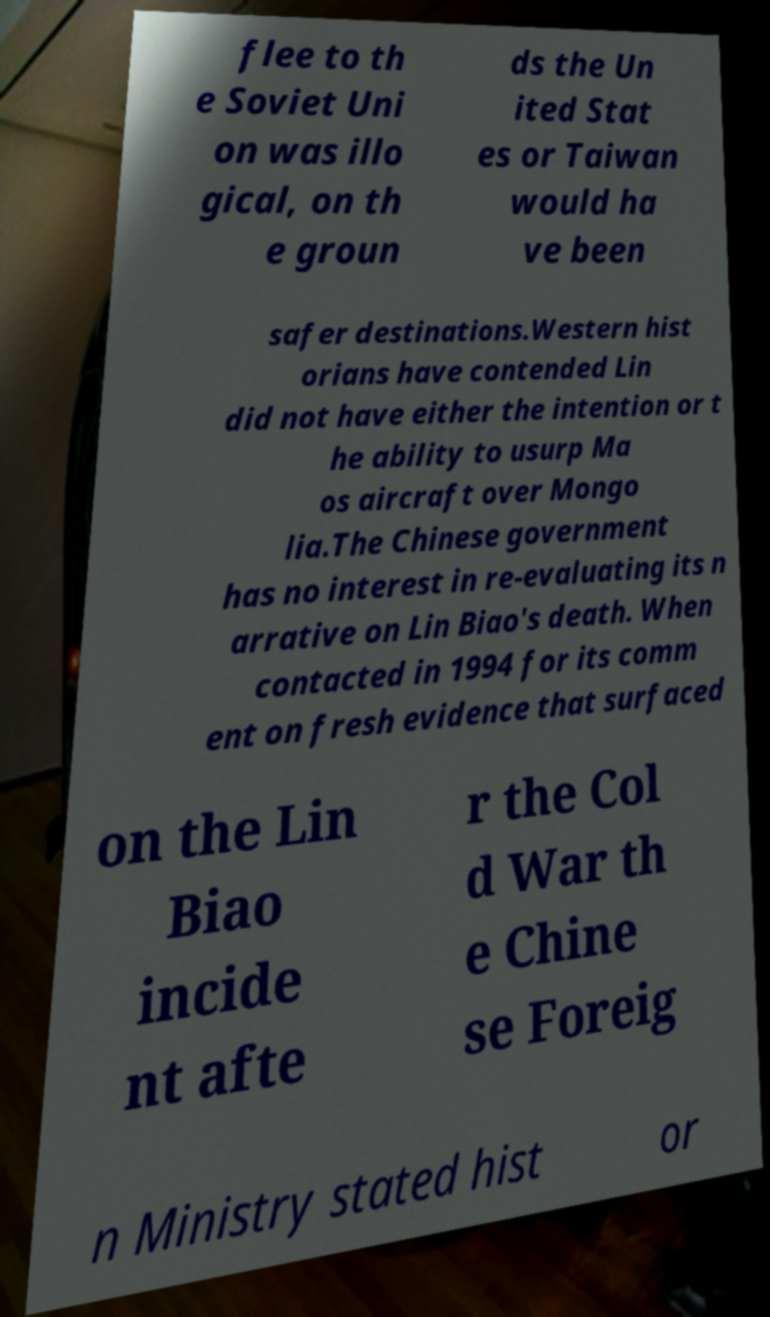Can you accurately transcribe the text from the provided image for me? flee to th e Soviet Uni on was illo gical, on th e groun ds the Un ited Stat es or Taiwan would ha ve been safer destinations.Western hist orians have contended Lin did not have either the intention or t he ability to usurp Ma os aircraft over Mongo lia.The Chinese government has no interest in re-evaluating its n arrative on Lin Biao's death. When contacted in 1994 for its comm ent on fresh evidence that surfaced on the Lin Biao incide nt afte r the Col d War th e Chine se Foreig n Ministry stated hist or 